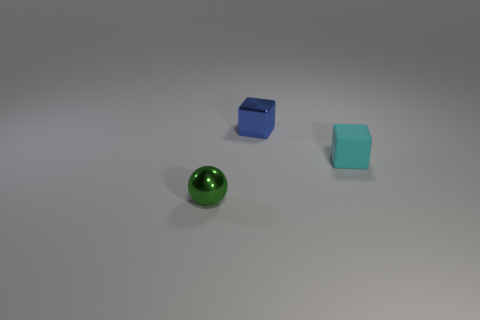Subtract all yellow balls. Subtract all brown blocks. How many balls are left? 1 Add 1 small cyan cubes. How many objects exist? 4 Subtract all spheres. How many objects are left? 2 Add 1 green balls. How many green balls exist? 2 Subtract 0 green blocks. How many objects are left? 3 Subtract all rubber cylinders. Subtract all small matte things. How many objects are left? 2 Add 2 shiny blocks. How many shiny blocks are left? 3 